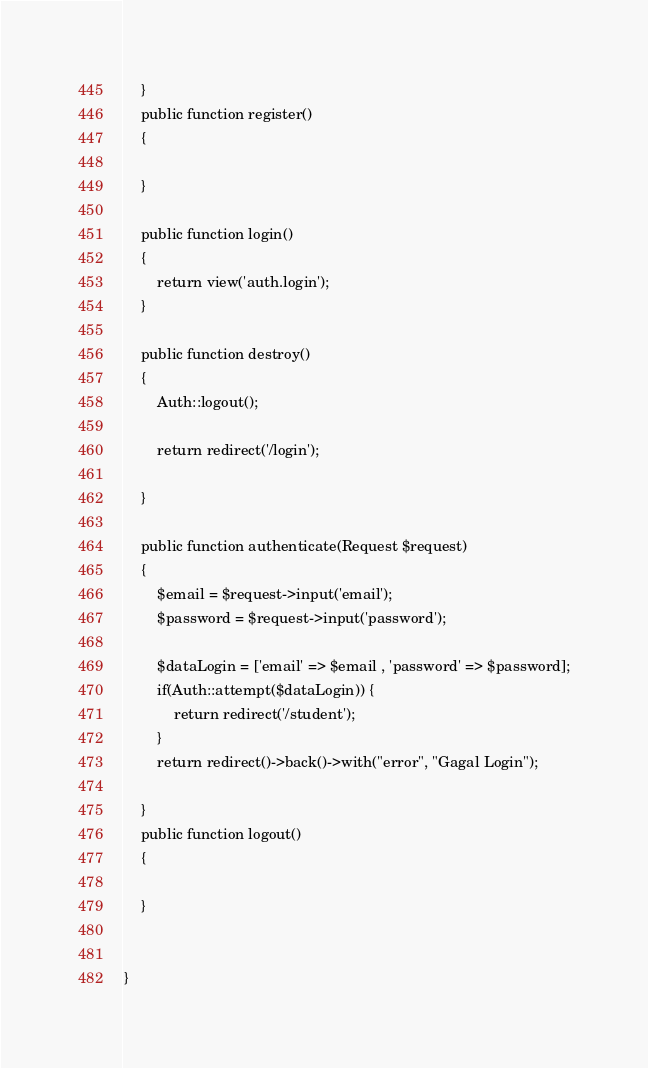Convert code to text. <code><loc_0><loc_0><loc_500><loc_500><_PHP_>    }
    public function register()
    {

    }

    public function login()
    {
        return view('auth.login');
    }

    public function destroy()
    {
        Auth::logout();
        
        return redirect('/login');
        
    }

    public function authenticate(Request $request)
    {
        $email = $request->input('email');
        $password = $request->input('password');

        $dataLogin = ['email' => $email , 'password' => $password];
        if(Auth::attempt($dataLogin)) {
            return redirect('/student');
        }
        return redirect()->back()->with("error", "Gagal Login");
        
    }
    public function logout()
    {

    }
  
    
}
</code> 